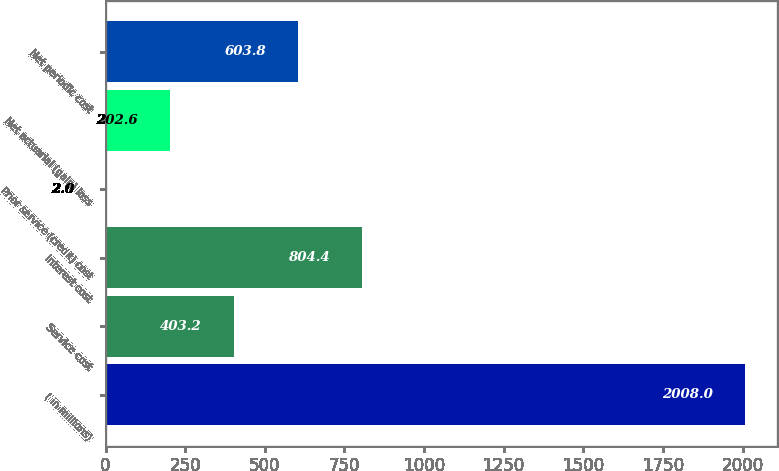Convert chart to OTSL. <chart><loc_0><loc_0><loc_500><loc_500><bar_chart><fcel>( in millions)<fcel>Service cost<fcel>Interest cost<fcel>Prior service (credit) cost<fcel>Net actuarial (gain) loss<fcel>Net periodic cost<nl><fcel>2008<fcel>403.2<fcel>804.4<fcel>2<fcel>202.6<fcel>603.8<nl></chart> 